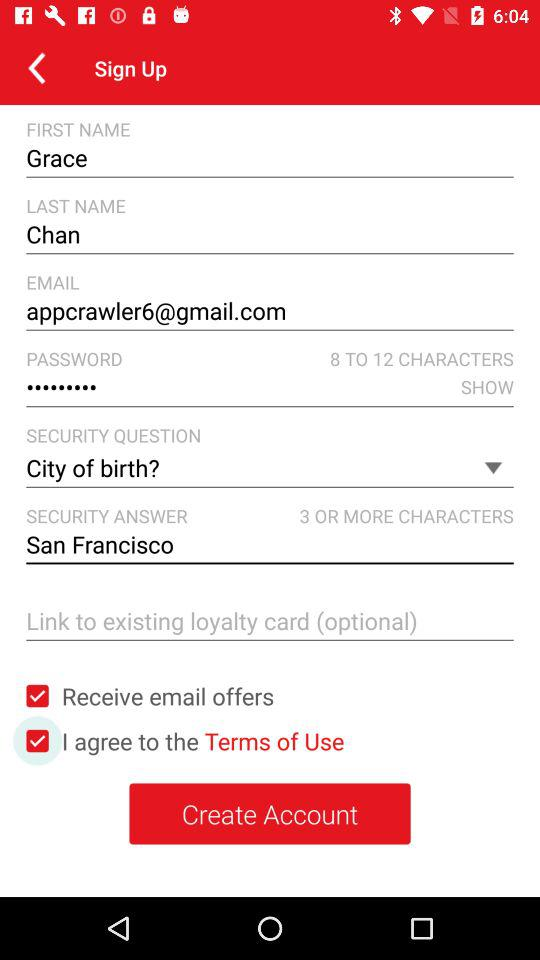What is the security question? The security question is "City of birth?". 